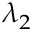Convert formula to latex. <formula><loc_0><loc_0><loc_500><loc_500>\lambda _ { 2 }</formula> 